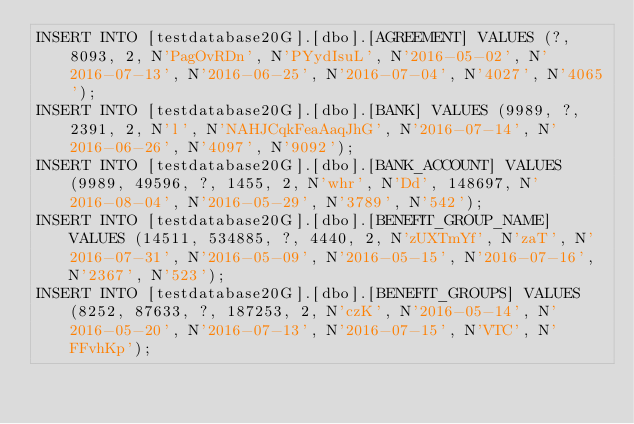<code> <loc_0><loc_0><loc_500><loc_500><_SQL_>INSERT INTO [testdatabase20G].[dbo].[AGREEMENT] VALUES (?, 8093, 2, N'PagOvRDn', N'PYydIsuL', N'2016-05-02', N'2016-07-13', N'2016-06-25', N'2016-07-04', N'4027', N'4065');
INSERT INTO [testdatabase20G].[dbo].[BANK] VALUES (9989, ?, 2391, 2, N'l', N'NAHJCqkFeaAaqJhG', N'2016-07-14', N'2016-06-26', N'4097', N'9092');
INSERT INTO [testdatabase20G].[dbo].[BANK_ACCOUNT] VALUES (9989, 49596, ?, 1455, 2, N'whr', N'Dd', 148697, N'2016-08-04', N'2016-05-29', N'3789', N'542');
INSERT INTO [testdatabase20G].[dbo].[BENEFIT_GROUP_NAME] VALUES (14511, 534885, ?, 4440, 2, N'zUXTmYf', N'zaT', N'2016-07-31', N'2016-05-09', N'2016-05-15', N'2016-07-16', N'2367', N'523');
INSERT INTO [testdatabase20G].[dbo].[BENEFIT_GROUPS] VALUES (8252, 87633, ?, 187253, 2, N'czK', N'2016-05-14', N'2016-05-20', N'2016-07-13', N'2016-07-15', N'VTC', N'FFvhKp');</code> 